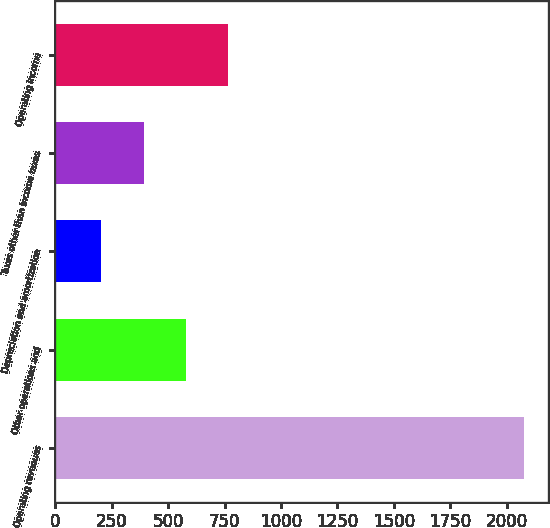Convert chart to OTSL. <chart><loc_0><loc_0><loc_500><loc_500><bar_chart><fcel>Operating revenues<fcel>Other operations and<fcel>Depreciation and amortization<fcel>Taxes other than income taxes<fcel>Operating income<nl><fcel>2078<fcel>579.6<fcel>205<fcel>392.3<fcel>766.9<nl></chart> 